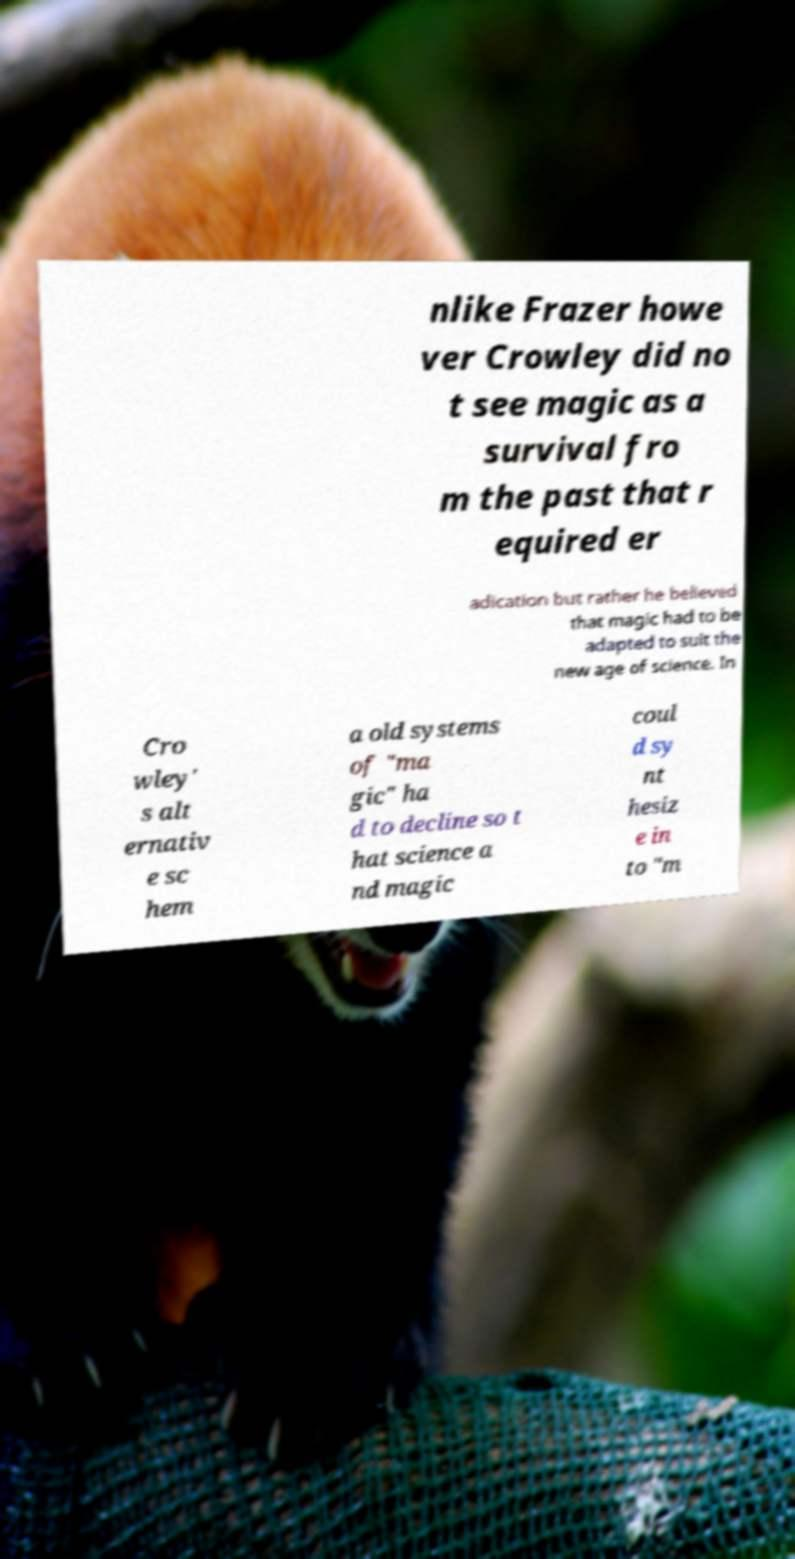Please read and relay the text visible in this image. What does it say? nlike Frazer howe ver Crowley did no t see magic as a survival fro m the past that r equired er adication but rather he believed that magic had to be adapted to suit the new age of science. In Cro wley' s alt ernativ e sc hem a old systems of "ma gic" ha d to decline so t hat science a nd magic coul d sy nt hesiz e in to "m 